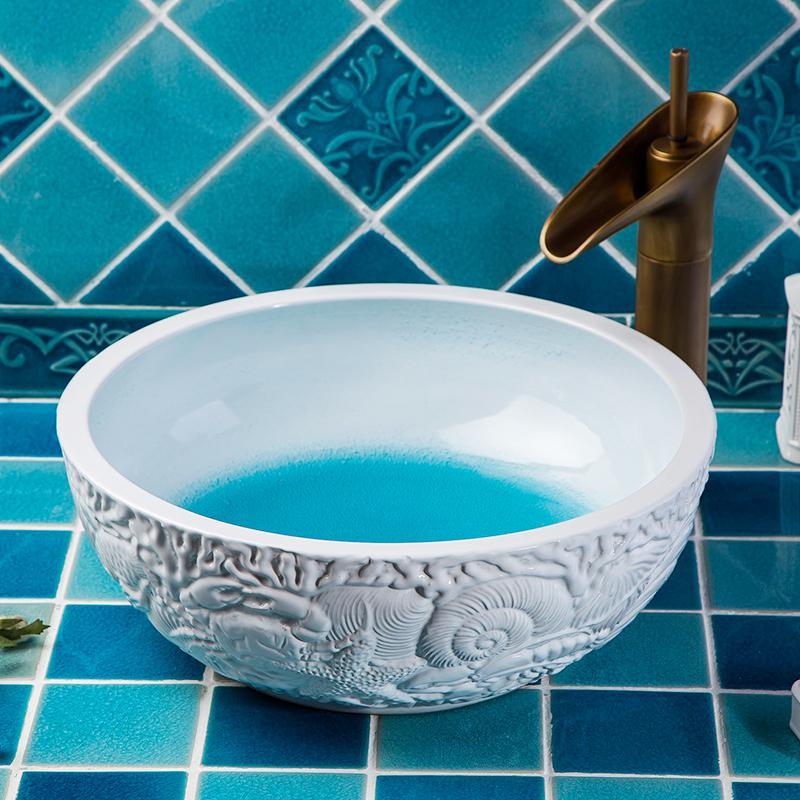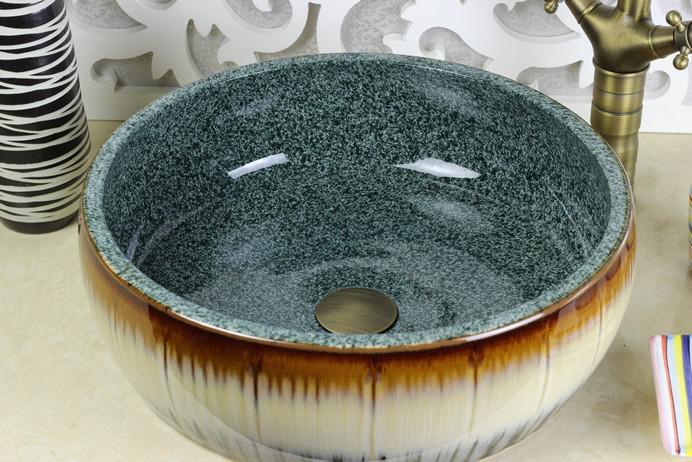The first image is the image on the left, the second image is the image on the right. For the images shown, is this caption "A gold-colored spout extends over a vessel sink with a decorated exterior set atop a tile counter in the left image, and the right image shows a sink with a hole inside." true? Answer yes or no. Yes. 